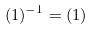Convert formula to latex. <formula><loc_0><loc_0><loc_500><loc_500>( 1 ) ^ { - 1 } = ( 1 )</formula> 